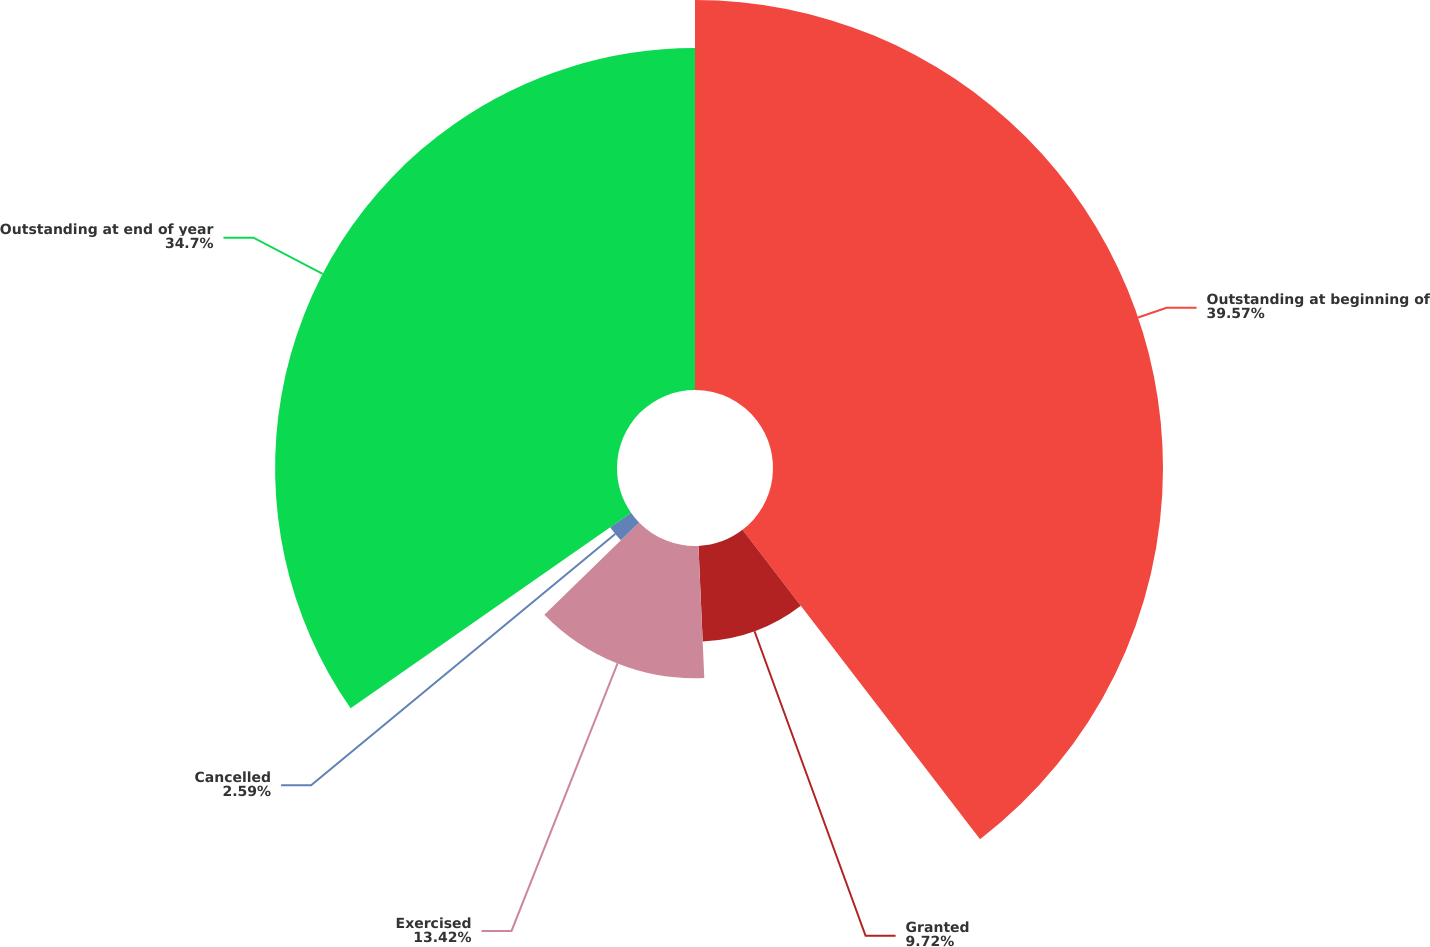Convert chart. <chart><loc_0><loc_0><loc_500><loc_500><pie_chart><fcel>Outstanding at beginning of<fcel>Granted<fcel>Exercised<fcel>Cancelled<fcel>Outstanding at end of year<nl><fcel>39.58%<fcel>9.72%<fcel>13.42%<fcel>2.59%<fcel>34.7%<nl></chart> 